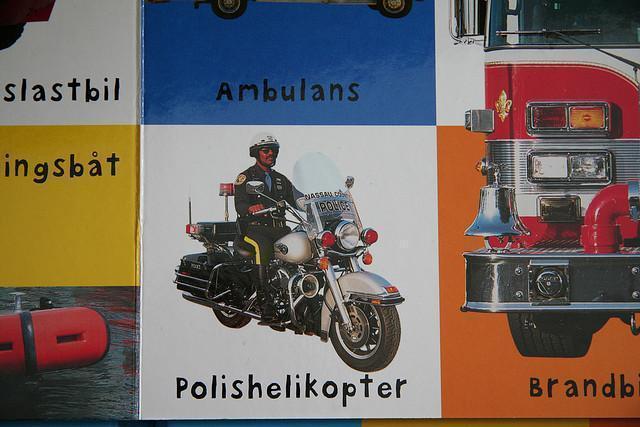What is the profession of the man on a motorcycle?
Select the correct answer and articulate reasoning with the following format: 'Answer: answer
Rationale: rationale.'
Options: Athlete, fireman, officer, lifeguard. Answer: officer.
Rationale: The man is wearing a police uniform as he is on a police motorcycle which indicates his workplace. 